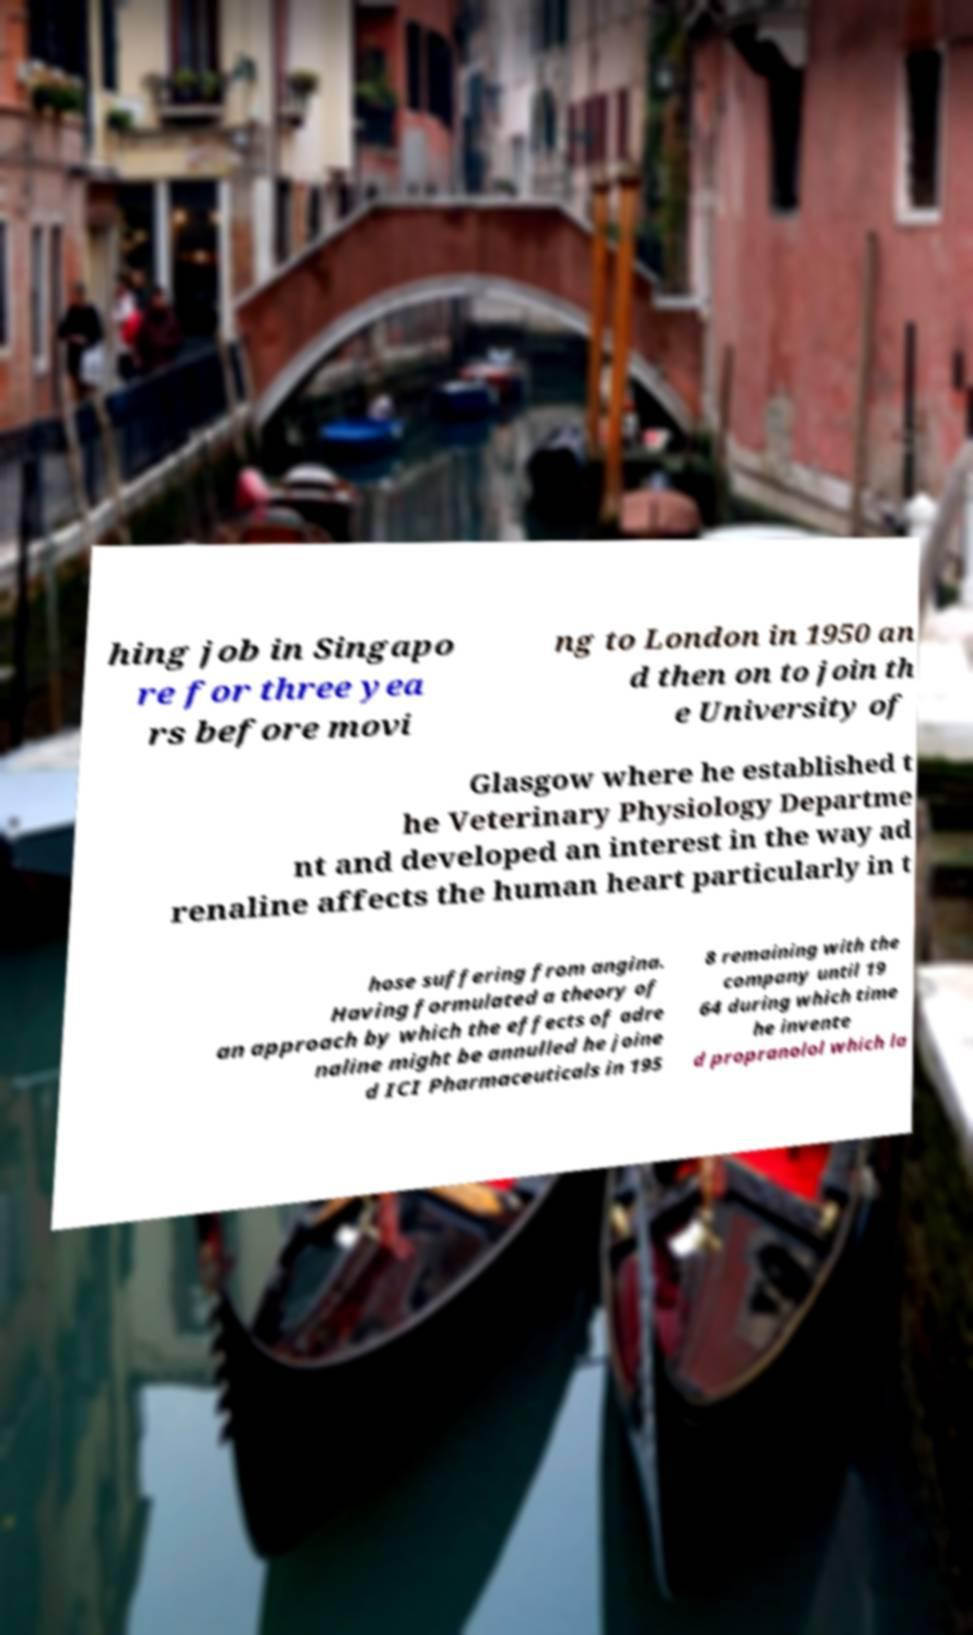Could you assist in decoding the text presented in this image and type it out clearly? hing job in Singapo re for three yea rs before movi ng to London in 1950 an d then on to join th e University of Glasgow where he established t he Veterinary Physiology Departme nt and developed an interest in the way ad renaline affects the human heart particularly in t hose suffering from angina. Having formulated a theory of an approach by which the effects of adre naline might be annulled he joine d ICI Pharmaceuticals in 195 8 remaining with the company until 19 64 during which time he invente d propranolol which la 